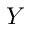Convert formula to latex. <formula><loc_0><loc_0><loc_500><loc_500>Y</formula> 